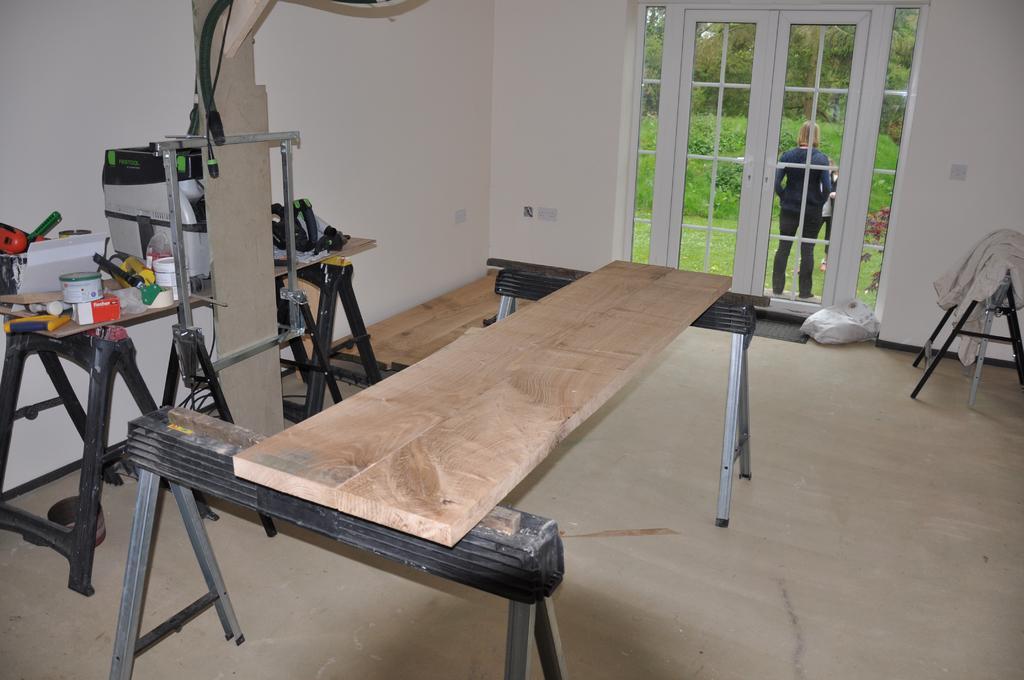Please provide a concise description of this image. This picture is clicked inside the room. In this picture, we see the stands on which wooden plank is placed. Beside that, we see a wooden table and stand on which many objects are placed. Beside that, we see the stand. Behind that, we see a white wall. On the right side, we see a stand on which white color cloth is placed. Beside that, we see a plastic cover. In the background, we see the glass door from which we can see the trees, shrubs, grass and two people are standing. 